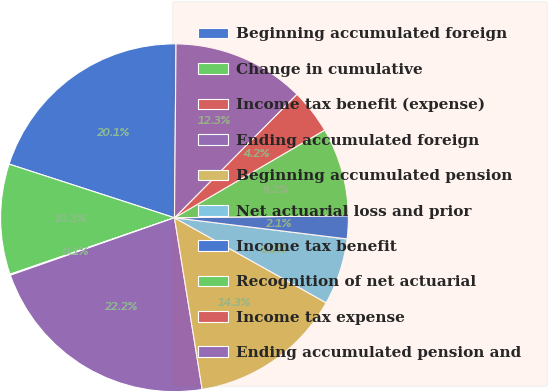<chart> <loc_0><loc_0><loc_500><loc_500><pie_chart><fcel>Beginning accumulated foreign<fcel>Change in cumulative<fcel>Income tax benefit (expense)<fcel>Ending accumulated foreign<fcel>Beginning accumulated pension<fcel>Net actuarial loss and prior<fcel>Income tax benefit<fcel>Recognition of net actuarial<fcel>Income tax expense<fcel>Ending accumulated pension and<nl><fcel>20.15%<fcel>10.26%<fcel>0.09%<fcel>22.19%<fcel>14.32%<fcel>6.19%<fcel>2.13%<fcel>8.22%<fcel>4.16%<fcel>12.29%<nl></chart> 